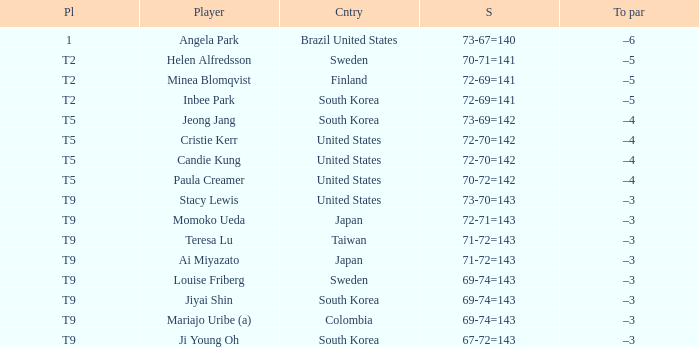What was Momoko Ueda's place? T9. Could you parse the entire table as a dict? {'header': ['Pl', 'Player', 'Cntry', 'S', 'To par'], 'rows': [['1', 'Angela Park', 'Brazil United States', '73-67=140', '–6'], ['T2', 'Helen Alfredsson', 'Sweden', '70-71=141', '–5'], ['T2', 'Minea Blomqvist', 'Finland', '72-69=141', '–5'], ['T2', 'Inbee Park', 'South Korea', '72-69=141', '–5'], ['T5', 'Jeong Jang', 'South Korea', '73-69=142', '–4'], ['T5', 'Cristie Kerr', 'United States', '72-70=142', '–4'], ['T5', 'Candie Kung', 'United States', '72-70=142', '–4'], ['T5', 'Paula Creamer', 'United States', '70-72=142', '–4'], ['T9', 'Stacy Lewis', 'United States', '73-70=143', '–3'], ['T9', 'Momoko Ueda', 'Japan', '72-71=143', '–3'], ['T9', 'Teresa Lu', 'Taiwan', '71-72=143', '–3'], ['T9', 'Ai Miyazato', 'Japan', '71-72=143', '–3'], ['T9', 'Louise Friberg', 'Sweden', '69-74=143', '–3'], ['T9', 'Jiyai Shin', 'South Korea', '69-74=143', '–3'], ['T9', 'Mariajo Uribe (a)', 'Colombia', '69-74=143', '–3'], ['T9', 'Ji Young Oh', 'South Korea', '67-72=143', '–3']]} 